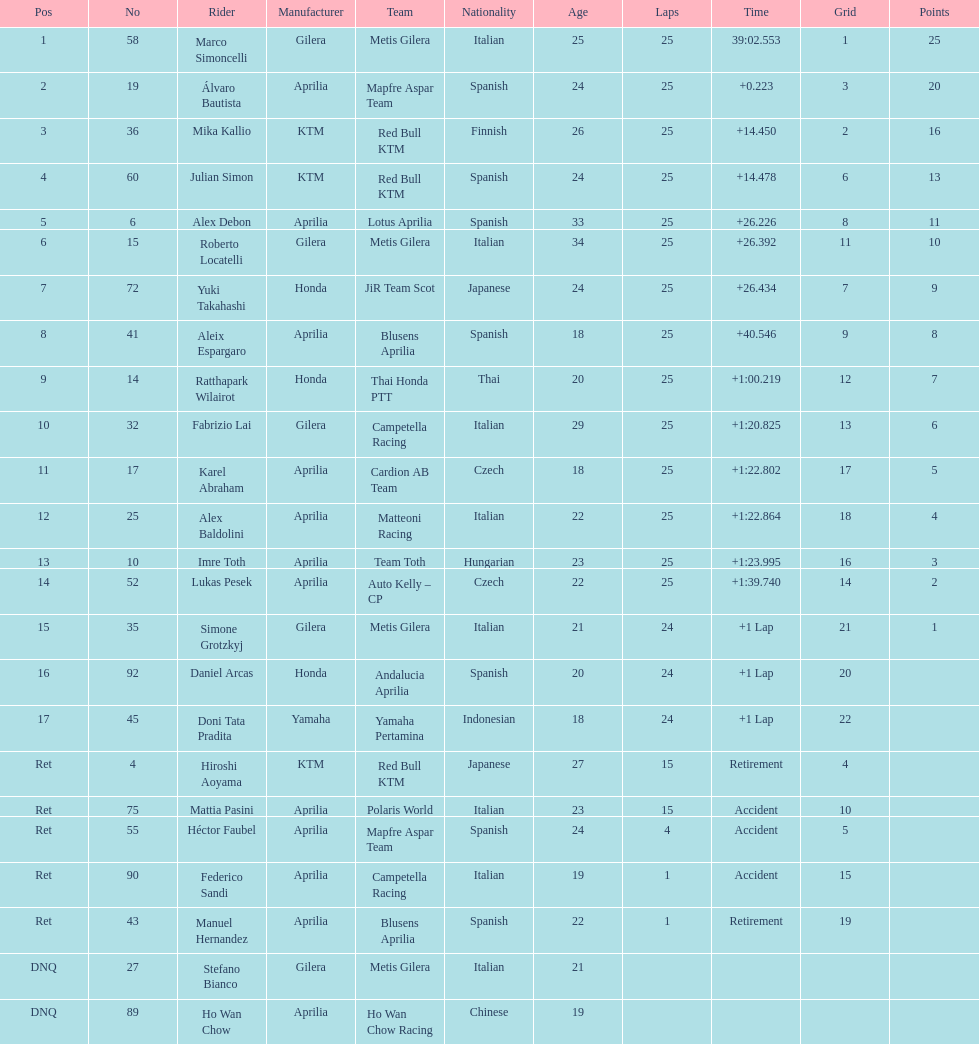The next rider from italy aside from winner marco simoncelli was Roberto Locatelli. 